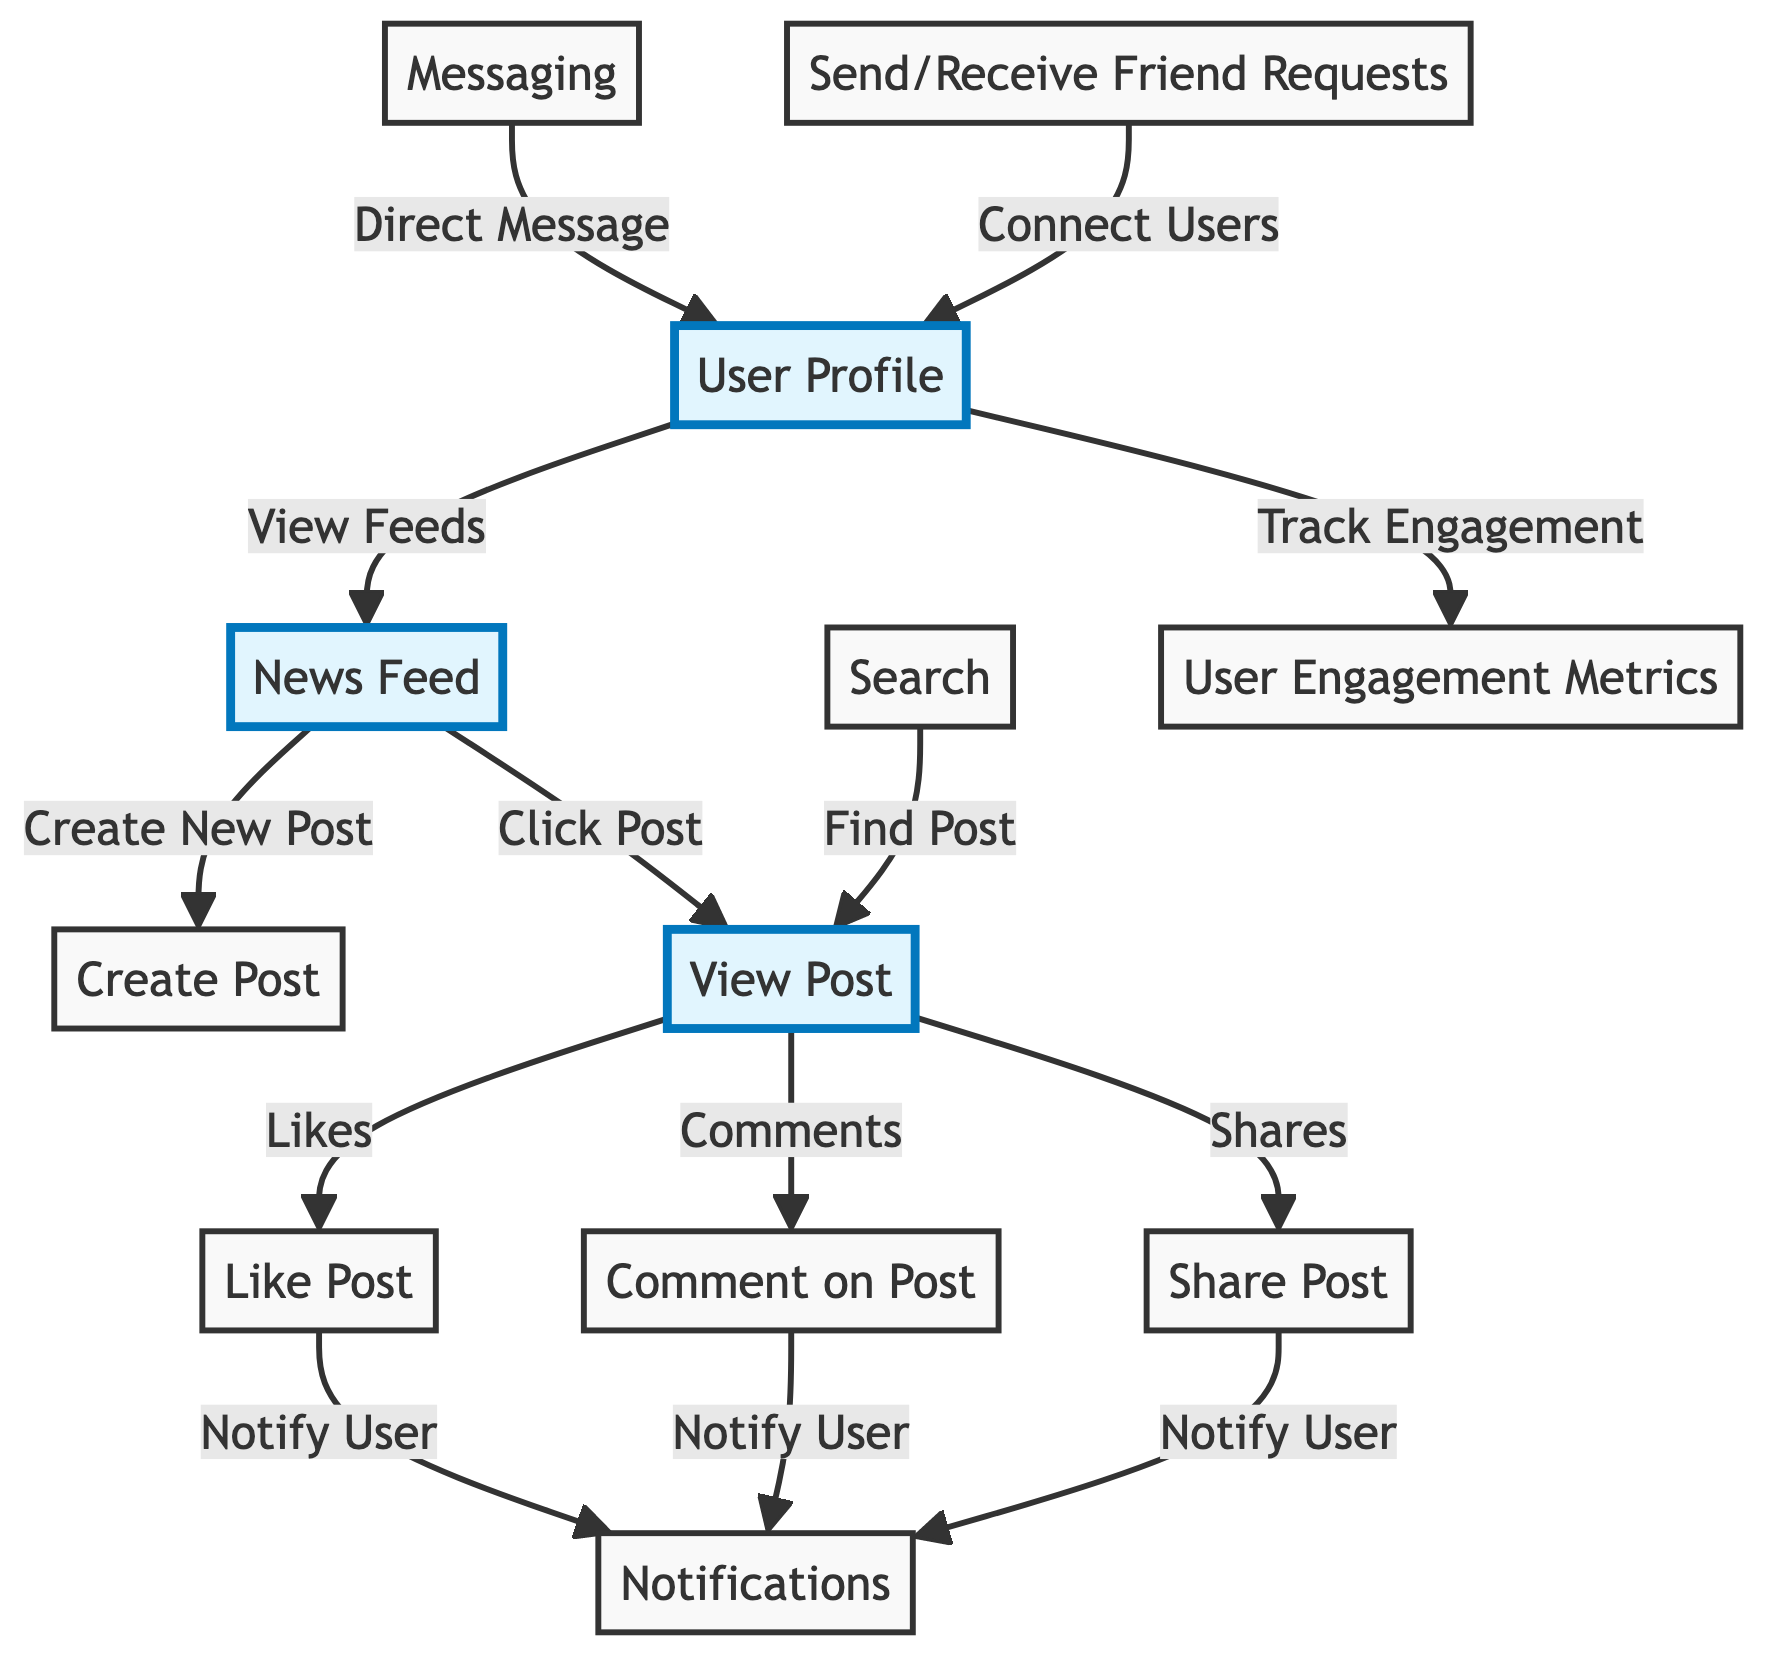What node receives notifications after a post is liked? The "Like Post" node connects to the "Notifications" node, indicating that after a user likes a post, a notification is sent.
Answer: Notifications How many user interaction nodes are in the diagram? The nodes related to user interactions include "View Post," "Like Post," "Comment on Post," "Share Post," and "Messaging." Counting these gives a total of five interaction nodes.
Answer: Five What action leads directly to "Create Post"? The "News Feed" node has a direct edge to the "Create Post" node, meaning that the action of viewing the feed can lead to creating a new post.
Answer: Create New Post What nodes are highlighted in the diagram? The nodes highlighted include "User Profile," "News Feed," and "View Post," indicating their importance in user engagement.
Answer: User Profile, News Feed, View Post Which node tracks user engagement metrics? The diagram shows that the "User Profile" node tracks user engagement metrics, connecting directly to the "User Engagement Metrics" node.
Answer: User Engagement Metrics What does the "Search" node lead to? The "Search" node connects to the "View Post" node, showing that searching results in viewing a specific post.
Answer: View Post Which interaction node results in notifying users? The nodes "Like Post," "Comment on Post," and "Share Post" all connect to "Notifications," indicating they result in user notifications when engaged.
Answer: Notify User How do users connect with others in the diagram? The "Send/Receive Friend Requests" node connects to the "User Profile" node, indicating that this action allows users to connect with others.
Answer: Connect Users What is the primary flow after viewing a post? After viewing a post, users can engage in multiple actions: they can like, comment, or share the post, which reflects the primary engagement actions.
Answer: Likes, Comments, Shares 